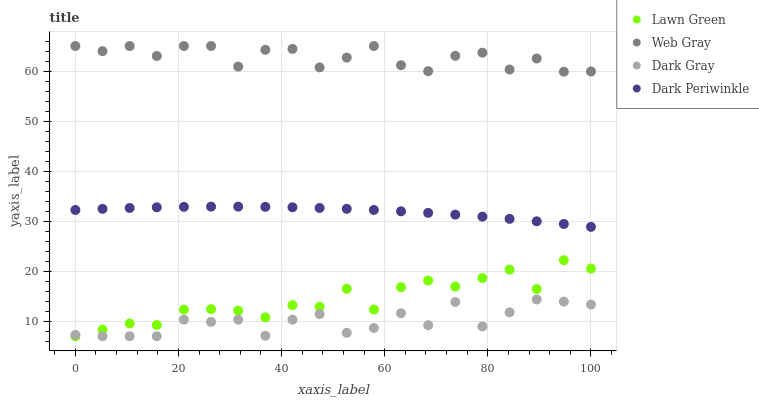Does Dark Gray have the minimum area under the curve?
Answer yes or no. Yes. Does Web Gray have the maximum area under the curve?
Answer yes or no. Yes. Does Lawn Green have the minimum area under the curve?
Answer yes or no. No. Does Lawn Green have the maximum area under the curve?
Answer yes or no. No. Is Dark Periwinkle the smoothest?
Answer yes or no. Yes. Is Web Gray the roughest?
Answer yes or no. Yes. Is Lawn Green the smoothest?
Answer yes or no. No. Is Lawn Green the roughest?
Answer yes or no. No. Does Dark Gray have the lowest value?
Answer yes or no. Yes. Does Web Gray have the lowest value?
Answer yes or no. No. Does Web Gray have the highest value?
Answer yes or no. Yes. Does Lawn Green have the highest value?
Answer yes or no. No. Is Dark Gray less than Web Gray?
Answer yes or no. Yes. Is Dark Periwinkle greater than Lawn Green?
Answer yes or no. Yes. Does Lawn Green intersect Dark Gray?
Answer yes or no. Yes. Is Lawn Green less than Dark Gray?
Answer yes or no. No. Is Lawn Green greater than Dark Gray?
Answer yes or no. No. Does Dark Gray intersect Web Gray?
Answer yes or no. No. 